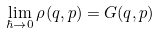Convert formula to latex. <formula><loc_0><loc_0><loc_500><loc_500>\lim _ { \hbar { \rightarrow } 0 } \rho _ { } ( q , p ) = G ( q , p ) \,</formula> 